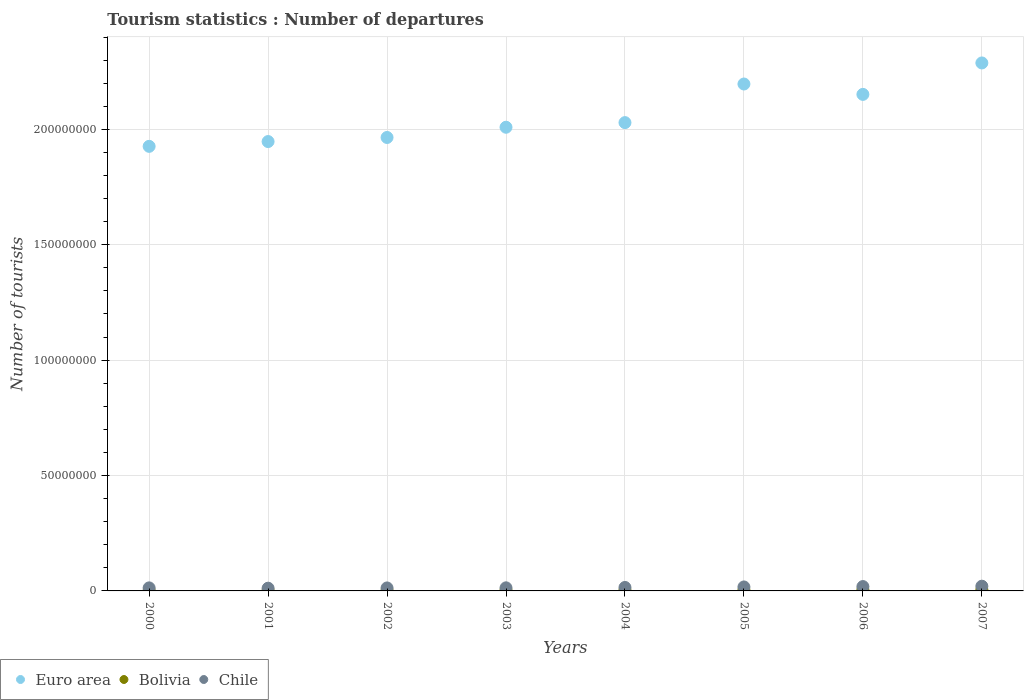How many different coloured dotlines are there?
Give a very brief answer. 3. Is the number of dotlines equal to the number of legend labels?
Ensure brevity in your answer.  Yes. What is the number of tourist departures in Bolivia in 2001?
Offer a very short reply. 2.22e+05. Across all years, what is the maximum number of tourist departures in Bolivia?
Make the answer very short. 5.26e+05. Across all years, what is the minimum number of tourist departures in Bolivia?
Offer a terse response. 2.01e+05. In which year was the number of tourist departures in Euro area minimum?
Your answer should be very brief. 2000. What is the total number of tourist departures in Bolivia in the graph?
Your answer should be compact. 2.67e+06. What is the difference between the number of tourist departures in Chile in 2006 and that in 2007?
Provide a short and direct response. -1.60e+05. What is the difference between the number of tourist departures in Chile in 2006 and the number of tourist departures in Euro area in 2000?
Provide a short and direct response. -1.91e+08. What is the average number of tourist departures in Euro area per year?
Provide a short and direct response. 2.06e+08. In the year 2006, what is the difference between the number of tourist departures in Chile and number of tourist departures in Bolivia?
Give a very brief answer. 1.42e+06. What is the ratio of the number of tourist departures in Euro area in 2003 to that in 2007?
Your answer should be compact. 0.88. Is the number of tourist departures in Chile in 2004 less than that in 2006?
Provide a succinct answer. Yes. What is the difference between the highest and the second highest number of tourist departures in Chile?
Provide a succinct answer. 1.60e+05. What is the difference between the highest and the lowest number of tourist departures in Euro area?
Provide a short and direct response. 3.61e+07. In how many years, is the number of tourist departures in Euro area greater than the average number of tourist departures in Euro area taken over all years?
Your response must be concise. 3. Is the sum of the number of tourist departures in Bolivia in 2000 and 2001 greater than the maximum number of tourist departures in Euro area across all years?
Make the answer very short. No. Is it the case that in every year, the sum of the number of tourist departures in Bolivia and number of tourist departures in Chile  is greater than the number of tourist departures in Euro area?
Your answer should be very brief. No. Does the number of tourist departures in Euro area monotonically increase over the years?
Offer a terse response. No. Is the number of tourist departures in Bolivia strictly greater than the number of tourist departures in Euro area over the years?
Offer a terse response. No. Is the number of tourist departures in Bolivia strictly less than the number of tourist departures in Chile over the years?
Provide a succinct answer. Yes. What is the difference between two consecutive major ticks on the Y-axis?
Offer a terse response. 5.00e+07. Does the graph contain any zero values?
Give a very brief answer. No. Does the graph contain grids?
Your response must be concise. Yes. How are the legend labels stacked?
Offer a terse response. Horizontal. What is the title of the graph?
Offer a terse response. Tourism statistics : Number of departures. What is the label or title of the X-axis?
Provide a short and direct response. Years. What is the label or title of the Y-axis?
Your answer should be very brief. Number of tourists. What is the Number of tourists of Euro area in 2000?
Make the answer very short. 1.93e+08. What is the Number of tourists of Bolivia in 2000?
Make the answer very short. 2.01e+05. What is the Number of tourists of Chile in 2000?
Your answer should be very brief. 1.32e+06. What is the Number of tourists of Euro area in 2001?
Keep it short and to the point. 1.95e+08. What is the Number of tourists in Bolivia in 2001?
Keep it short and to the point. 2.22e+05. What is the Number of tourists of Chile in 2001?
Ensure brevity in your answer.  1.18e+06. What is the Number of tourists of Euro area in 2002?
Make the answer very short. 1.96e+08. What is the Number of tourists of Bolivia in 2002?
Your answer should be very brief. 2.17e+05. What is the Number of tourists in Chile in 2002?
Keep it short and to the point. 1.29e+06. What is the Number of tourists of Euro area in 2003?
Offer a terse response. 2.01e+08. What is the Number of tourists of Bolivia in 2003?
Offer a terse response. 3.04e+05. What is the Number of tourists in Chile in 2003?
Your answer should be very brief. 1.34e+06. What is the Number of tourists of Euro area in 2004?
Provide a short and direct response. 2.03e+08. What is the Number of tourists of Bolivia in 2004?
Ensure brevity in your answer.  3.46e+05. What is the Number of tourists in Chile in 2004?
Your response must be concise. 1.50e+06. What is the Number of tourists in Euro area in 2005?
Make the answer very short. 2.20e+08. What is the Number of tourists of Bolivia in 2005?
Keep it short and to the point. 3.86e+05. What is the Number of tourists in Chile in 2005?
Offer a terse response. 1.72e+06. What is the Number of tourists in Euro area in 2006?
Provide a succinct answer. 2.15e+08. What is the Number of tourists in Bolivia in 2006?
Provide a short and direct response. 4.72e+05. What is the Number of tourists of Chile in 2006?
Your response must be concise. 1.89e+06. What is the Number of tourists in Euro area in 2007?
Your response must be concise. 2.29e+08. What is the Number of tourists in Bolivia in 2007?
Offer a very short reply. 5.26e+05. What is the Number of tourists of Chile in 2007?
Offer a terse response. 2.05e+06. Across all years, what is the maximum Number of tourists in Euro area?
Your response must be concise. 2.29e+08. Across all years, what is the maximum Number of tourists of Bolivia?
Offer a very short reply. 5.26e+05. Across all years, what is the maximum Number of tourists of Chile?
Provide a succinct answer. 2.05e+06. Across all years, what is the minimum Number of tourists in Euro area?
Give a very brief answer. 1.93e+08. Across all years, what is the minimum Number of tourists of Bolivia?
Give a very brief answer. 2.01e+05. Across all years, what is the minimum Number of tourists of Chile?
Provide a succinct answer. 1.18e+06. What is the total Number of tourists of Euro area in the graph?
Your response must be concise. 1.65e+09. What is the total Number of tourists in Bolivia in the graph?
Your answer should be compact. 2.67e+06. What is the total Number of tourists in Chile in the graph?
Make the answer very short. 1.23e+07. What is the difference between the Number of tourists of Euro area in 2000 and that in 2001?
Provide a succinct answer. -2.08e+06. What is the difference between the Number of tourists in Bolivia in 2000 and that in 2001?
Make the answer very short. -2.10e+04. What is the difference between the Number of tourists of Chile in 2000 and that in 2001?
Your response must be concise. 1.39e+05. What is the difference between the Number of tourists of Euro area in 2000 and that in 2002?
Make the answer very short. -3.85e+06. What is the difference between the Number of tourists of Bolivia in 2000 and that in 2002?
Keep it short and to the point. -1.60e+04. What is the difference between the Number of tourists in Chile in 2000 and that in 2002?
Offer a terse response. 2.60e+04. What is the difference between the Number of tourists in Euro area in 2000 and that in 2003?
Your response must be concise. -8.28e+06. What is the difference between the Number of tourists in Bolivia in 2000 and that in 2003?
Offer a very short reply. -1.03e+05. What is the difference between the Number of tourists of Chile in 2000 and that in 2003?
Make the answer very short. -2.20e+04. What is the difference between the Number of tourists in Euro area in 2000 and that in 2004?
Provide a short and direct response. -1.03e+07. What is the difference between the Number of tourists in Bolivia in 2000 and that in 2004?
Offer a very short reply. -1.45e+05. What is the difference between the Number of tourists in Chile in 2000 and that in 2004?
Make the answer very short. -1.85e+05. What is the difference between the Number of tourists in Euro area in 2000 and that in 2005?
Your answer should be compact. -2.70e+07. What is the difference between the Number of tourists of Bolivia in 2000 and that in 2005?
Offer a very short reply. -1.85e+05. What is the difference between the Number of tourists of Chile in 2000 and that in 2005?
Make the answer very short. -4.06e+05. What is the difference between the Number of tourists in Euro area in 2000 and that in 2006?
Ensure brevity in your answer.  -2.25e+07. What is the difference between the Number of tourists of Bolivia in 2000 and that in 2006?
Ensure brevity in your answer.  -2.71e+05. What is the difference between the Number of tourists in Chile in 2000 and that in 2006?
Make the answer very short. -5.68e+05. What is the difference between the Number of tourists in Euro area in 2000 and that in 2007?
Keep it short and to the point. -3.61e+07. What is the difference between the Number of tourists in Bolivia in 2000 and that in 2007?
Your response must be concise. -3.25e+05. What is the difference between the Number of tourists of Chile in 2000 and that in 2007?
Provide a succinct answer. -7.28e+05. What is the difference between the Number of tourists in Euro area in 2001 and that in 2002?
Provide a succinct answer. -1.77e+06. What is the difference between the Number of tourists in Bolivia in 2001 and that in 2002?
Your answer should be compact. 5000. What is the difference between the Number of tourists in Chile in 2001 and that in 2002?
Give a very brief answer. -1.13e+05. What is the difference between the Number of tourists in Euro area in 2001 and that in 2003?
Ensure brevity in your answer.  -6.20e+06. What is the difference between the Number of tourists in Bolivia in 2001 and that in 2003?
Offer a very short reply. -8.20e+04. What is the difference between the Number of tourists in Chile in 2001 and that in 2003?
Provide a short and direct response. -1.61e+05. What is the difference between the Number of tourists in Euro area in 2001 and that in 2004?
Give a very brief answer. -8.20e+06. What is the difference between the Number of tourists of Bolivia in 2001 and that in 2004?
Make the answer very short. -1.24e+05. What is the difference between the Number of tourists of Chile in 2001 and that in 2004?
Provide a succinct answer. -3.24e+05. What is the difference between the Number of tourists in Euro area in 2001 and that in 2005?
Ensure brevity in your answer.  -2.49e+07. What is the difference between the Number of tourists in Bolivia in 2001 and that in 2005?
Your answer should be compact. -1.64e+05. What is the difference between the Number of tourists in Chile in 2001 and that in 2005?
Offer a terse response. -5.45e+05. What is the difference between the Number of tourists of Euro area in 2001 and that in 2006?
Ensure brevity in your answer.  -2.04e+07. What is the difference between the Number of tourists of Bolivia in 2001 and that in 2006?
Your response must be concise. -2.50e+05. What is the difference between the Number of tourists in Chile in 2001 and that in 2006?
Provide a short and direct response. -7.07e+05. What is the difference between the Number of tourists of Euro area in 2001 and that in 2007?
Keep it short and to the point. -3.41e+07. What is the difference between the Number of tourists of Bolivia in 2001 and that in 2007?
Provide a succinct answer. -3.04e+05. What is the difference between the Number of tourists in Chile in 2001 and that in 2007?
Give a very brief answer. -8.67e+05. What is the difference between the Number of tourists in Euro area in 2002 and that in 2003?
Provide a succinct answer. -4.43e+06. What is the difference between the Number of tourists in Bolivia in 2002 and that in 2003?
Keep it short and to the point. -8.70e+04. What is the difference between the Number of tourists of Chile in 2002 and that in 2003?
Provide a short and direct response. -4.80e+04. What is the difference between the Number of tourists in Euro area in 2002 and that in 2004?
Offer a very short reply. -6.44e+06. What is the difference between the Number of tourists in Bolivia in 2002 and that in 2004?
Ensure brevity in your answer.  -1.29e+05. What is the difference between the Number of tourists of Chile in 2002 and that in 2004?
Make the answer very short. -2.11e+05. What is the difference between the Number of tourists of Euro area in 2002 and that in 2005?
Give a very brief answer. -2.32e+07. What is the difference between the Number of tourists in Bolivia in 2002 and that in 2005?
Keep it short and to the point. -1.69e+05. What is the difference between the Number of tourists in Chile in 2002 and that in 2005?
Your response must be concise. -4.32e+05. What is the difference between the Number of tourists of Euro area in 2002 and that in 2006?
Keep it short and to the point. -1.87e+07. What is the difference between the Number of tourists of Bolivia in 2002 and that in 2006?
Offer a terse response. -2.55e+05. What is the difference between the Number of tourists in Chile in 2002 and that in 2006?
Give a very brief answer. -5.94e+05. What is the difference between the Number of tourists of Euro area in 2002 and that in 2007?
Ensure brevity in your answer.  -3.23e+07. What is the difference between the Number of tourists in Bolivia in 2002 and that in 2007?
Offer a very short reply. -3.09e+05. What is the difference between the Number of tourists of Chile in 2002 and that in 2007?
Your answer should be compact. -7.54e+05. What is the difference between the Number of tourists in Euro area in 2003 and that in 2004?
Offer a terse response. -2.00e+06. What is the difference between the Number of tourists in Bolivia in 2003 and that in 2004?
Make the answer very short. -4.20e+04. What is the difference between the Number of tourists in Chile in 2003 and that in 2004?
Offer a very short reply. -1.63e+05. What is the difference between the Number of tourists of Euro area in 2003 and that in 2005?
Make the answer very short. -1.87e+07. What is the difference between the Number of tourists of Bolivia in 2003 and that in 2005?
Your response must be concise. -8.20e+04. What is the difference between the Number of tourists of Chile in 2003 and that in 2005?
Give a very brief answer. -3.84e+05. What is the difference between the Number of tourists in Euro area in 2003 and that in 2006?
Give a very brief answer. -1.42e+07. What is the difference between the Number of tourists of Bolivia in 2003 and that in 2006?
Your answer should be compact. -1.68e+05. What is the difference between the Number of tourists in Chile in 2003 and that in 2006?
Your answer should be very brief. -5.46e+05. What is the difference between the Number of tourists of Euro area in 2003 and that in 2007?
Your answer should be very brief. -2.79e+07. What is the difference between the Number of tourists in Bolivia in 2003 and that in 2007?
Make the answer very short. -2.22e+05. What is the difference between the Number of tourists of Chile in 2003 and that in 2007?
Provide a succinct answer. -7.06e+05. What is the difference between the Number of tourists of Euro area in 2004 and that in 2005?
Offer a very short reply. -1.67e+07. What is the difference between the Number of tourists in Bolivia in 2004 and that in 2005?
Offer a terse response. -4.00e+04. What is the difference between the Number of tourists in Chile in 2004 and that in 2005?
Make the answer very short. -2.21e+05. What is the difference between the Number of tourists in Euro area in 2004 and that in 2006?
Give a very brief answer. -1.22e+07. What is the difference between the Number of tourists in Bolivia in 2004 and that in 2006?
Provide a succinct answer. -1.26e+05. What is the difference between the Number of tourists of Chile in 2004 and that in 2006?
Ensure brevity in your answer.  -3.83e+05. What is the difference between the Number of tourists of Euro area in 2004 and that in 2007?
Keep it short and to the point. -2.59e+07. What is the difference between the Number of tourists in Chile in 2004 and that in 2007?
Give a very brief answer. -5.43e+05. What is the difference between the Number of tourists of Euro area in 2005 and that in 2006?
Ensure brevity in your answer.  4.50e+06. What is the difference between the Number of tourists in Bolivia in 2005 and that in 2006?
Ensure brevity in your answer.  -8.60e+04. What is the difference between the Number of tourists in Chile in 2005 and that in 2006?
Your response must be concise. -1.62e+05. What is the difference between the Number of tourists in Euro area in 2005 and that in 2007?
Offer a very short reply. -9.13e+06. What is the difference between the Number of tourists in Bolivia in 2005 and that in 2007?
Give a very brief answer. -1.40e+05. What is the difference between the Number of tourists of Chile in 2005 and that in 2007?
Offer a very short reply. -3.22e+05. What is the difference between the Number of tourists in Euro area in 2006 and that in 2007?
Ensure brevity in your answer.  -1.36e+07. What is the difference between the Number of tourists of Bolivia in 2006 and that in 2007?
Your answer should be very brief. -5.40e+04. What is the difference between the Number of tourists in Chile in 2006 and that in 2007?
Offer a very short reply. -1.60e+05. What is the difference between the Number of tourists in Euro area in 2000 and the Number of tourists in Bolivia in 2001?
Keep it short and to the point. 1.92e+08. What is the difference between the Number of tourists of Euro area in 2000 and the Number of tourists of Chile in 2001?
Your answer should be very brief. 1.91e+08. What is the difference between the Number of tourists of Bolivia in 2000 and the Number of tourists of Chile in 2001?
Provide a succinct answer. -9.79e+05. What is the difference between the Number of tourists of Euro area in 2000 and the Number of tourists of Bolivia in 2002?
Offer a terse response. 1.92e+08. What is the difference between the Number of tourists of Euro area in 2000 and the Number of tourists of Chile in 2002?
Your answer should be very brief. 1.91e+08. What is the difference between the Number of tourists in Bolivia in 2000 and the Number of tourists in Chile in 2002?
Offer a terse response. -1.09e+06. What is the difference between the Number of tourists of Euro area in 2000 and the Number of tourists of Bolivia in 2003?
Offer a very short reply. 1.92e+08. What is the difference between the Number of tourists in Euro area in 2000 and the Number of tourists in Chile in 2003?
Provide a succinct answer. 1.91e+08. What is the difference between the Number of tourists in Bolivia in 2000 and the Number of tourists in Chile in 2003?
Provide a short and direct response. -1.14e+06. What is the difference between the Number of tourists in Euro area in 2000 and the Number of tourists in Bolivia in 2004?
Make the answer very short. 1.92e+08. What is the difference between the Number of tourists of Euro area in 2000 and the Number of tourists of Chile in 2004?
Offer a very short reply. 1.91e+08. What is the difference between the Number of tourists in Bolivia in 2000 and the Number of tourists in Chile in 2004?
Provide a succinct answer. -1.30e+06. What is the difference between the Number of tourists in Euro area in 2000 and the Number of tourists in Bolivia in 2005?
Offer a terse response. 1.92e+08. What is the difference between the Number of tourists in Euro area in 2000 and the Number of tourists in Chile in 2005?
Keep it short and to the point. 1.91e+08. What is the difference between the Number of tourists in Bolivia in 2000 and the Number of tourists in Chile in 2005?
Keep it short and to the point. -1.52e+06. What is the difference between the Number of tourists of Euro area in 2000 and the Number of tourists of Bolivia in 2006?
Ensure brevity in your answer.  1.92e+08. What is the difference between the Number of tourists of Euro area in 2000 and the Number of tourists of Chile in 2006?
Your answer should be compact. 1.91e+08. What is the difference between the Number of tourists of Bolivia in 2000 and the Number of tourists of Chile in 2006?
Provide a succinct answer. -1.69e+06. What is the difference between the Number of tourists in Euro area in 2000 and the Number of tourists in Bolivia in 2007?
Your response must be concise. 1.92e+08. What is the difference between the Number of tourists in Euro area in 2000 and the Number of tourists in Chile in 2007?
Your answer should be very brief. 1.91e+08. What is the difference between the Number of tourists in Bolivia in 2000 and the Number of tourists in Chile in 2007?
Give a very brief answer. -1.85e+06. What is the difference between the Number of tourists of Euro area in 2001 and the Number of tourists of Bolivia in 2002?
Your response must be concise. 1.95e+08. What is the difference between the Number of tourists of Euro area in 2001 and the Number of tourists of Chile in 2002?
Give a very brief answer. 1.93e+08. What is the difference between the Number of tourists in Bolivia in 2001 and the Number of tourists in Chile in 2002?
Give a very brief answer. -1.07e+06. What is the difference between the Number of tourists in Euro area in 2001 and the Number of tourists in Bolivia in 2003?
Give a very brief answer. 1.94e+08. What is the difference between the Number of tourists of Euro area in 2001 and the Number of tourists of Chile in 2003?
Provide a succinct answer. 1.93e+08. What is the difference between the Number of tourists in Bolivia in 2001 and the Number of tourists in Chile in 2003?
Provide a short and direct response. -1.12e+06. What is the difference between the Number of tourists in Euro area in 2001 and the Number of tourists in Bolivia in 2004?
Offer a very short reply. 1.94e+08. What is the difference between the Number of tourists of Euro area in 2001 and the Number of tourists of Chile in 2004?
Your answer should be compact. 1.93e+08. What is the difference between the Number of tourists of Bolivia in 2001 and the Number of tourists of Chile in 2004?
Offer a terse response. -1.28e+06. What is the difference between the Number of tourists of Euro area in 2001 and the Number of tourists of Bolivia in 2005?
Provide a succinct answer. 1.94e+08. What is the difference between the Number of tourists of Euro area in 2001 and the Number of tourists of Chile in 2005?
Your answer should be compact. 1.93e+08. What is the difference between the Number of tourists of Bolivia in 2001 and the Number of tourists of Chile in 2005?
Offer a terse response. -1.50e+06. What is the difference between the Number of tourists of Euro area in 2001 and the Number of tourists of Bolivia in 2006?
Provide a succinct answer. 1.94e+08. What is the difference between the Number of tourists in Euro area in 2001 and the Number of tourists in Chile in 2006?
Ensure brevity in your answer.  1.93e+08. What is the difference between the Number of tourists in Bolivia in 2001 and the Number of tourists in Chile in 2006?
Your answer should be compact. -1.66e+06. What is the difference between the Number of tourists in Euro area in 2001 and the Number of tourists in Bolivia in 2007?
Make the answer very short. 1.94e+08. What is the difference between the Number of tourists of Euro area in 2001 and the Number of tourists of Chile in 2007?
Make the answer very short. 1.93e+08. What is the difference between the Number of tourists in Bolivia in 2001 and the Number of tourists in Chile in 2007?
Keep it short and to the point. -1.82e+06. What is the difference between the Number of tourists of Euro area in 2002 and the Number of tourists of Bolivia in 2003?
Your answer should be very brief. 1.96e+08. What is the difference between the Number of tourists in Euro area in 2002 and the Number of tourists in Chile in 2003?
Your answer should be compact. 1.95e+08. What is the difference between the Number of tourists in Bolivia in 2002 and the Number of tourists in Chile in 2003?
Make the answer very short. -1.12e+06. What is the difference between the Number of tourists in Euro area in 2002 and the Number of tourists in Bolivia in 2004?
Offer a very short reply. 1.96e+08. What is the difference between the Number of tourists of Euro area in 2002 and the Number of tourists of Chile in 2004?
Your answer should be very brief. 1.95e+08. What is the difference between the Number of tourists in Bolivia in 2002 and the Number of tourists in Chile in 2004?
Give a very brief answer. -1.29e+06. What is the difference between the Number of tourists of Euro area in 2002 and the Number of tourists of Bolivia in 2005?
Your answer should be compact. 1.96e+08. What is the difference between the Number of tourists of Euro area in 2002 and the Number of tourists of Chile in 2005?
Offer a very short reply. 1.95e+08. What is the difference between the Number of tourists of Bolivia in 2002 and the Number of tourists of Chile in 2005?
Your answer should be very brief. -1.51e+06. What is the difference between the Number of tourists in Euro area in 2002 and the Number of tourists in Bolivia in 2006?
Offer a very short reply. 1.96e+08. What is the difference between the Number of tourists of Euro area in 2002 and the Number of tourists of Chile in 2006?
Your answer should be very brief. 1.95e+08. What is the difference between the Number of tourists of Bolivia in 2002 and the Number of tourists of Chile in 2006?
Offer a terse response. -1.67e+06. What is the difference between the Number of tourists of Euro area in 2002 and the Number of tourists of Bolivia in 2007?
Provide a short and direct response. 1.96e+08. What is the difference between the Number of tourists in Euro area in 2002 and the Number of tourists in Chile in 2007?
Your response must be concise. 1.94e+08. What is the difference between the Number of tourists of Bolivia in 2002 and the Number of tourists of Chile in 2007?
Your answer should be very brief. -1.83e+06. What is the difference between the Number of tourists of Euro area in 2003 and the Number of tourists of Bolivia in 2004?
Ensure brevity in your answer.  2.01e+08. What is the difference between the Number of tourists in Euro area in 2003 and the Number of tourists in Chile in 2004?
Provide a succinct answer. 1.99e+08. What is the difference between the Number of tourists of Bolivia in 2003 and the Number of tourists of Chile in 2004?
Provide a short and direct response. -1.20e+06. What is the difference between the Number of tourists of Euro area in 2003 and the Number of tourists of Bolivia in 2005?
Provide a short and direct response. 2.01e+08. What is the difference between the Number of tourists of Euro area in 2003 and the Number of tourists of Chile in 2005?
Provide a short and direct response. 1.99e+08. What is the difference between the Number of tourists in Bolivia in 2003 and the Number of tourists in Chile in 2005?
Keep it short and to the point. -1.42e+06. What is the difference between the Number of tourists of Euro area in 2003 and the Number of tourists of Bolivia in 2006?
Your response must be concise. 2.00e+08. What is the difference between the Number of tourists in Euro area in 2003 and the Number of tourists in Chile in 2006?
Offer a very short reply. 1.99e+08. What is the difference between the Number of tourists in Bolivia in 2003 and the Number of tourists in Chile in 2006?
Give a very brief answer. -1.58e+06. What is the difference between the Number of tourists in Euro area in 2003 and the Number of tourists in Bolivia in 2007?
Your answer should be very brief. 2.00e+08. What is the difference between the Number of tourists in Euro area in 2003 and the Number of tourists in Chile in 2007?
Provide a short and direct response. 1.99e+08. What is the difference between the Number of tourists of Bolivia in 2003 and the Number of tourists of Chile in 2007?
Provide a short and direct response. -1.74e+06. What is the difference between the Number of tourists of Euro area in 2004 and the Number of tourists of Bolivia in 2005?
Your response must be concise. 2.03e+08. What is the difference between the Number of tourists in Euro area in 2004 and the Number of tourists in Chile in 2005?
Your answer should be compact. 2.01e+08. What is the difference between the Number of tourists in Bolivia in 2004 and the Number of tourists in Chile in 2005?
Provide a succinct answer. -1.38e+06. What is the difference between the Number of tourists of Euro area in 2004 and the Number of tourists of Bolivia in 2006?
Offer a terse response. 2.02e+08. What is the difference between the Number of tourists in Euro area in 2004 and the Number of tourists in Chile in 2006?
Ensure brevity in your answer.  2.01e+08. What is the difference between the Number of tourists in Bolivia in 2004 and the Number of tourists in Chile in 2006?
Provide a succinct answer. -1.54e+06. What is the difference between the Number of tourists of Euro area in 2004 and the Number of tourists of Bolivia in 2007?
Keep it short and to the point. 2.02e+08. What is the difference between the Number of tourists of Euro area in 2004 and the Number of tourists of Chile in 2007?
Offer a terse response. 2.01e+08. What is the difference between the Number of tourists in Bolivia in 2004 and the Number of tourists in Chile in 2007?
Provide a short and direct response. -1.70e+06. What is the difference between the Number of tourists in Euro area in 2005 and the Number of tourists in Bolivia in 2006?
Your answer should be very brief. 2.19e+08. What is the difference between the Number of tourists of Euro area in 2005 and the Number of tourists of Chile in 2006?
Your response must be concise. 2.18e+08. What is the difference between the Number of tourists of Bolivia in 2005 and the Number of tourists of Chile in 2006?
Give a very brief answer. -1.50e+06. What is the difference between the Number of tourists in Euro area in 2005 and the Number of tourists in Bolivia in 2007?
Offer a terse response. 2.19e+08. What is the difference between the Number of tourists of Euro area in 2005 and the Number of tourists of Chile in 2007?
Your answer should be compact. 2.18e+08. What is the difference between the Number of tourists of Bolivia in 2005 and the Number of tourists of Chile in 2007?
Ensure brevity in your answer.  -1.66e+06. What is the difference between the Number of tourists of Euro area in 2006 and the Number of tourists of Bolivia in 2007?
Offer a terse response. 2.15e+08. What is the difference between the Number of tourists of Euro area in 2006 and the Number of tourists of Chile in 2007?
Keep it short and to the point. 2.13e+08. What is the difference between the Number of tourists in Bolivia in 2006 and the Number of tourists in Chile in 2007?
Offer a very short reply. -1.58e+06. What is the average Number of tourists in Euro area per year?
Provide a succinct answer. 2.06e+08. What is the average Number of tourists in Bolivia per year?
Your answer should be very brief. 3.34e+05. What is the average Number of tourists in Chile per year?
Make the answer very short. 1.54e+06. In the year 2000, what is the difference between the Number of tourists of Euro area and Number of tourists of Bolivia?
Your answer should be very brief. 1.92e+08. In the year 2000, what is the difference between the Number of tourists of Euro area and Number of tourists of Chile?
Make the answer very short. 1.91e+08. In the year 2000, what is the difference between the Number of tourists of Bolivia and Number of tourists of Chile?
Offer a terse response. -1.12e+06. In the year 2001, what is the difference between the Number of tourists of Euro area and Number of tourists of Bolivia?
Provide a succinct answer. 1.95e+08. In the year 2001, what is the difference between the Number of tourists in Euro area and Number of tourists in Chile?
Offer a terse response. 1.94e+08. In the year 2001, what is the difference between the Number of tourists of Bolivia and Number of tourists of Chile?
Provide a succinct answer. -9.58e+05. In the year 2002, what is the difference between the Number of tourists of Euro area and Number of tourists of Bolivia?
Ensure brevity in your answer.  1.96e+08. In the year 2002, what is the difference between the Number of tourists of Euro area and Number of tourists of Chile?
Your answer should be very brief. 1.95e+08. In the year 2002, what is the difference between the Number of tourists of Bolivia and Number of tourists of Chile?
Provide a succinct answer. -1.08e+06. In the year 2003, what is the difference between the Number of tourists of Euro area and Number of tourists of Bolivia?
Offer a terse response. 2.01e+08. In the year 2003, what is the difference between the Number of tourists of Euro area and Number of tourists of Chile?
Your answer should be compact. 2.00e+08. In the year 2003, what is the difference between the Number of tourists of Bolivia and Number of tourists of Chile?
Offer a terse response. -1.04e+06. In the year 2004, what is the difference between the Number of tourists of Euro area and Number of tourists of Bolivia?
Keep it short and to the point. 2.03e+08. In the year 2004, what is the difference between the Number of tourists in Euro area and Number of tourists in Chile?
Make the answer very short. 2.01e+08. In the year 2004, what is the difference between the Number of tourists in Bolivia and Number of tourists in Chile?
Offer a terse response. -1.16e+06. In the year 2005, what is the difference between the Number of tourists in Euro area and Number of tourists in Bolivia?
Your response must be concise. 2.19e+08. In the year 2005, what is the difference between the Number of tourists of Euro area and Number of tourists of Chile?
Provide a short and direct response. 2.18e+08. In the year 2005, what is the difference between the Number of tourists of Bolivia and Number of tourists of Chile?
Your response must be concise. -1.34e+06. In the year 2006, what is the difference between the Number of tourists of Euro area and Number of tourists of Bolivia?
Your answer should be compact. 2.15e+08. In the year 2006, what is the difference between the Number of tourists in Euro area and Number of tourists in Chile?
Your answer should be very brief. 2.13e+08. In the year 2006, what is the difference between the Number of tourists in Bolivia and Number of tourists in Chile?
Your response must be concise. -1.42e+06. In the year 2007, what is the difference between the Number of tourists in Euro area and Number of tourists in Bolivia?
Provide a short and direct response. 2.28e+08. In the year 2007, what is the difference between the Number of tourists in Euro area and Number of tourists in Chile?
Your response must be concise. 2.27e+08. In the year 2007, what is the difference between the Number of tourists of Bolivia and Number of tourists of Chile?
Provide a short and direct response. -1.52e+06. What is the ratio of the Number of tourists in Euro area in 2000 to that in 2001?
Your answer should be very brief. 0.99. What is the ratio of the Number of tourists of Bolivia in 2000 to that in 2001?
Your answer should be compact. 0.91. What is the ratio of the Number of tourists of Chile in 2000 to that in 2001?
Provide a succinct answer. 1.12. What is the ratio of the Number of tourists in Euro area in 2000 to that in 2002?
Your answer should be compact. 0.98. What is the ratio of the Number of tourists of Bolivia in 2000 to that in 2002?
Ensure brevity in your answer.  0.93. What is the ratio of the Number of tourists in Chile in 2000 to that in 2002?
Your answer should be very brief. 1.02. What is the ratio of the Number of tourists in Euro area in 2000 to that in 2003?
Keep it short and to the point. 0.96. What is the ratio of the Number of tourists of Bolivia in 2000 to that in 2003?
Your answer should be compact. 0.66. What is the ratio of the Number of tourists of Chile in 2000 to that in 2003?
Make the answer very short. 0.98. What is the ratio of the Number of tourists of Euro area in 2000 to that in 2004?
Your response must be concise. 0.95. What is the ratio of the Number of tourists of Bolivia in 2000 to that in 2004?
Your response must be concise. 0.58. What is the ratio of the Number of tourists in Chile in 2000 to that in 2004?
Provide a succinct answer. 0.88. What is the ratio of the Number of tourists of Euro area in 2000 to that in 2005?
Give a very brief answer. 0.88. What is the ratio of the Number of tourists of Bolivia in 2000 to that in 2005?
Offer a terse response. 0.52. What is the ratio of the Number of tourists of Chile in 2000 to that in 2005?
Provide a succinct answer. 0.76. What is the ratio of the Number of tourists in Euro area in 2000 to that in 2006?
Offer a terse response. 0.9. What is the ratio of the Number of tourists in Bolivia in 2000 to that in 2006?
Make the answer very short. 0.43. What is the ratio of the Number of tourists of Chile in 2000 to that in 2006?
Your answer should be compact. 0.7. What is the ratio of the Number of tourists in Euro area in 2000 to that in 2007?
Your response must be concise. 0.84. What is the ratio of the Number of tourists of Bolivia in 2000 to that in 2007?
Provide a short and direct response. 0.38. What is the ratio of the Number of tourists of Chile in 2000 to that in 2007?
Give a very brief answer. 0.64. What is the ratio of the Number of tourists of Chile in 2001 to that in 2002?
Ensure brevity in your answer.  0.91. What is the ratio of the Number of tourists in Euro area in 2001 to that in 2003?
Your answer should be compact. 0.97. What is the ratio of the Number of tourists in Bolivia in 2001 to that in 2003?
Offer a terse response. 0.73. What is the ratio of the Number of tourists of Chile in 2001 to that in 2003?
Offer a terse response. 0.88. What is the ratio of the Number of tourists of Euro area in 2001 to that in 2004?
Ensure brevity in your answer.  0.96. What is the ratio of the Number of tourists of Bolivia in 2001 to that in 2004?
Keep it short and to the point. 0.64. What is the ratio of the Number of tourists of Chile in 2001 to that in 2004?
Give a very brief answer. 0.78. What is the ratio of the Number of tourists in Euro area in 2001 to that in 2005?
Make the answer very short. 0.89. What is the ratio of the Number of tourists in Bolivia in 2001 to that in 2005?
Offer a very short reply. 0.58. What is the ratio of the Number of tourists in Chile in 2001 to that in 2005?
Offer a terse response. 0.68. What is the ratio of the Number of tourists of Euro area in 2001 to that in 2006?
Offer a very short reply. 0.91. What is the ratio of the Number of tourists in Bolivia in 2001 to that in 2006?
Offer a terse response. 0.47. What is the ratio of the Number of tourists in Chile in 2001 to that in 2006?
Ensure brevity in your answer.  0.63. What is the ratio of the Number of tourists in Euro area in 2001 to that in 2007?
Your response must be concise. 0.85. What is the ratio of the Number of tourists in Bolivia in 2001 to that in 2007?
Your answer should be compact. 0.42. What is the ratio of the Number of tourists in Chile in 2001 to that in 2007?
Your answer should be very brief. 0.58. What is the ratio of the Number of tourists in Euro area in 2002 to that in 2003?
Your answer should be compact. 0.98. What is the ratio of the Number of tourists in Bolivia in 2002 to that in 2003?
Your response must be concise. 0.71. What is the ratio of the Number of tourists in Chile in 2002 to that in 2003?
Offer a terse response. 0.96. What is the ratio of the Number of tourists in Euro area in 2002 to that in 2004?
Keep it short and to the point. 0.97. What is the ratio of the Number of tourists of Bolivia in 2002 to that in 2004?
Give a very brief answer. 0.63. What is the ratio of the Number of tourists of Chile in 2002 to that in 2004?
Make the answer very short. 0.86. What is the ratio of the Number of tourists of Euro area in 2002 to that in 2005?
Your response must be concise. 0.89. What is the ratio of the Number of tourists of Bolivia in 2002 to that in 2005?
Keep it short and to the point. 0.56. What is the ratio of the Number of tourists of Chile in 2002 to that in 2005?
Ensure brevity in your answer.  0.75. What is the ratio of the Number of tourists of Euro area in 2002 to that in 2006?
Your response must be concise. 0.91. What is the ratio of the Number of tourists of Bolivia in 2002 to that in 2006?
Ensure brevity in your answer.  0.46. What is the ratio of the Number of tourists in Chile in 2002 to that in 2006?
Keep it short and to the point. 0.69. What is the ratio of the Number of tourists of Euro area in 2002 to that in 2007?
Offer a terse response. 0.86. What is the ratio of the Number of tourists in Bolivia in 2002 to that in 2007?
Your response must be concise. 0.41. What is the ratio of the Number of tourists in Chile in 2002 to that in 2007?
Offer a very short reply. 0.63. What is the ratio of the Number of tourists of Bolivia in 2003 to that in 2004?
Your answer should be very brief. 0.88. What is the ratio of the Number of tourists of Chile in 2003 to that in 2004?
Provide a short and direct response. 0.89. What is the ratio of the Number of tourists in Euro area in 2003 to that in 2005?
Offer a very short reply. 0.91. What is the ratio of the Number of tourists in Bolivia in 2003 to that in 2005?
Provide a succinct answer. 0.79. What is the ratio of the Number of tourists in Chile in 2003 to that in 2005?
Offer a very short reply. 0.78. What is the ratio of the Number of tourists in Euro area in 2003 to that in 2006?
Your answer should be compact. 0.93. What is the ratio of the Number of tourists in Bolivia in 2003 to that in 2006?
Offer a very short reply. 0.64. What is the ratio of the Number of tourists of Chile in 2003 to that in 2006?
Offer a terse response. 0.71. What is the ratio of the Number of tourists of Euro area in 2003 to that in 2007?
Your answer should be very brief. 0.88. What is the ratio of the Number of tourists in Bolivia in 2003 to that in 2007?
Make the answer very short. 0.58. What is the ratio of the Number of tourists in Chile in 2003 to that in 2007?
Provide a short and direct response. 0.66. What is the ratio of the Number of tourists of Euro area in 2004 to that in 2005?
Offer a terse response. 0.92. What is the ratio of the Number of tourists of Bolivia in 2004 to that in 2005?
Ensure brevity in your answer.  0.9. What is the ratio of the Number of tourists of Chile in 2004 to that in 2005?
Your answer should be compact. 0.87. What is the ratio of the Number of tourists in Euro area in 2004 to that in 2006?
Your answer should be very brief. 0.94. What is the ratio of the Number of tourists in Bolivia in 2004 to that in 2006?
Provide a short and direct response. 0.73. What is the ratio of the Number of tourists in Chile in 2004 to that in 2006?
Ensure brevity in your answer.  0.8. What is the ratio of the Number of tourists in Euro area in 2004 to that in 2007?
Offer a terse response. 0.89. What is the ratio of the Number of tourists of Bolivia in 2004 to that in 2007?
Your answer should be very brief. 0.66. What is the ratio of the Number of tourists of Chile in 2004 to that in 2007?
Provide a short and direct response. 0.73. What is the ratio of the Number of tourists of Euro area in 2005 to that in 2006?
Your answer should be very brief. 1.02. What is the ratio of the Number of tourists of Bolivia in 2005 to that in 2006?
Ensure brevity in your answer.  0.82. What is the ratio of the Number of tourists in Chile in 2005 to that in 2006?
Provide a succinct answer. 0.91. What is the ratio of the Number of tourists in Euro area in 2005 to that in 2007?
Your response must be concise. 0.96. What is the ratio of the Number of tourists in Bolivia in 2005 to that in 2007?
Offer a terse response. 0.73. What is the ratio of the Number of tourists of Chile in 2005 to that in 2007?
Your response must be concise. 0.84. What is the ratio of the Number of tourists of Euro area in 2006 to that in 2007?
Give a very brief answer. 0.94. What is the ratio of the Number of tourists of Bolivia in 2006 to that in 2007?
Offer a terse response. 0.9. What is the ratio of the Number of tourists of Chile in 2006 to that in 2007?
Provide a short and direct response. 0.92. What is the difference between the highest and the second highest Number of tourists of Euro area?
Your answer should be compact. 9.13e+06. What is the difference between the highest and the second highest Number of tourists of Bolivia?
Ensure brevity in your answer.  5.40e+04. What is the difference between the highest and the lowest Number of tourists of Euro area?
Make the answer very short. 3.61e+07. What is the difference between the highest and the lowest Number of tourists in Bolivia?
Your answer should be very brief. 3.25e+05. What is the difference between the highest and the lowest Number of tourists in Chile?
Provide a succinct answer. 8.67e+05. 